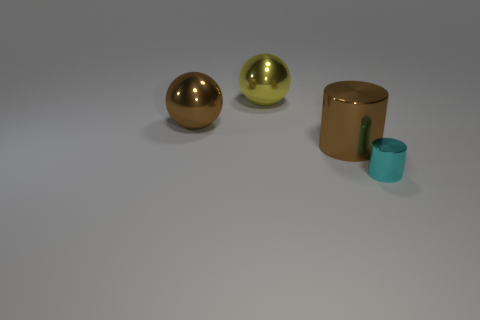Subtract 1 spheres. How many spheres are left? 1 Subtract 0 red cylinders. How many objects are left? 4 Subtract all green spheres. Subtract all green cubes. How many spheres are left? 2 Subtract all brown cylinders. How many brown spheres are left? 1 Subtract all large yellow things. Subtract all yellow rubber blocks. How many objects are left? 3 Add 2 cyan metal cylinders. How many cyan metal cylinders are left? 3 Add 2 large yellow objects. How many large yellow objects exist? 3 Add 3 cyan metallic objects. How many objects exist? 7 Subtract all brown spheres. How many spheres are left? 1 